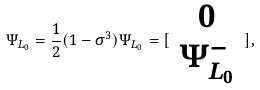Convert formula to latex. <formula><loc_0><loc_0><loc_500><loc_500>\Psi _ { L _ { 0 } } = \frac { 1 } { 2 } ( 1 - \sigma ^ { 3 } ) \Psi _ { L _ { 0 } } = [ \begin{array} { c } 0 \\ \Psi _ { L _ { 0 } } ^ { - } \end{array} ] ,</formula> 